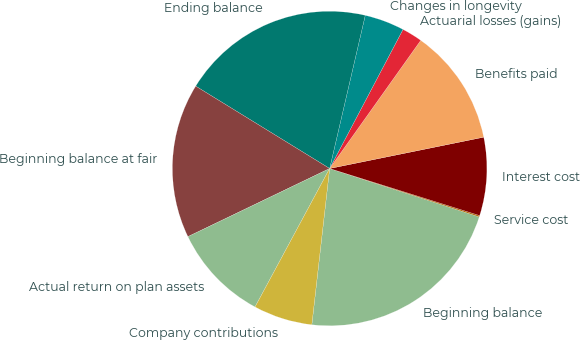<chart> <loc_0><loc_0><loc_500><loc_500><pie_chart><fcel>Beginning balance<fcel>Service cost<fcel>Interest cost<fcel>Benefits paid<fcel>Actuarial losses (gains)<fcel>Changes in longevity<fcel>Ending balance<fcel>Beginning balance at fair<fcel>Actual return on plan assets<fcel>Company contributions<nl><fcel>21.83%<fcel>0.14%<fcel>8.03%<fcel>11.97%<fcel>2.11%<fcel>4.09%<fcel>19.86%<fcel>15.91%<fcel>10.0%<fcel>6.06%<nl></chart> 